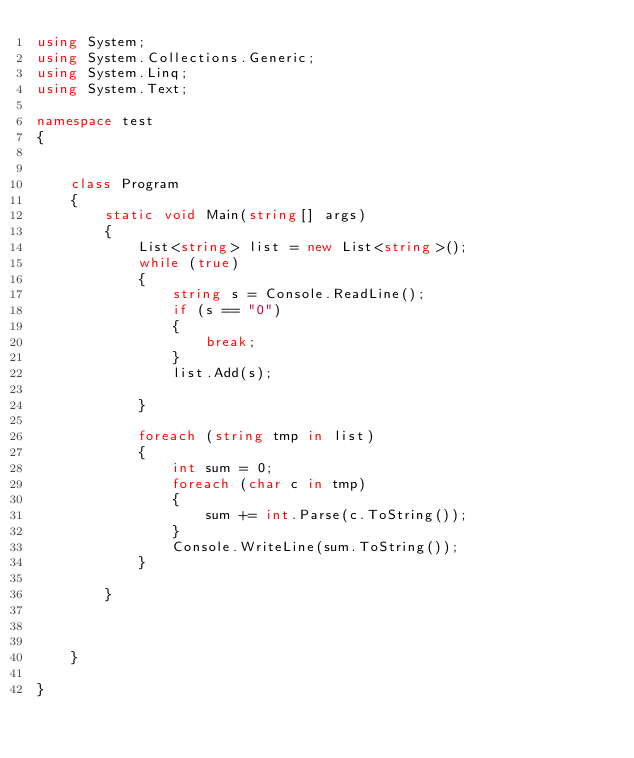Convert code to text. <code><loc_0><loc_0><loc_500><loc_500><_C#_>using System;
using System.Collections.Generic;
using System.Linq;
using System.Text;

namespace test
{


    class Program
    {
        static void Main(string[] args)
        {
            List<string> list = new List<string>();
            while (true)
            {
                string s = Console.ReadLine();
                if (s == "0")
                {
                    break;
                }
                list.Add(s);

            }

            foreach (string tmp in list)
            {
                int sum = 0;
                foreach (char c in tmp)
                {
                    sum += int.Parse(c.ToString());
                }
                Console.WriteLine(sum.ToString());
            }

        }

      

    }
        
}</code> 